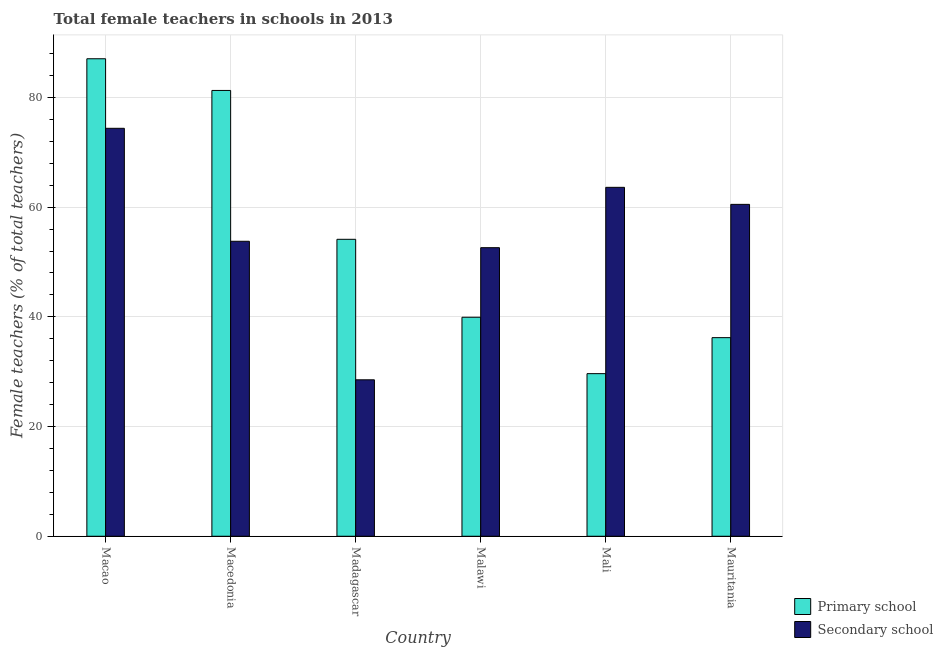Are the number of bars per tick equal to the number of legend labels?
Offer a terse response. Yes. How many bars are there on the 4th tick from the left?
Your response must be concise. 2. How many bars are there on the 6th tick from the right?
Your answer should be very brief. 2. What is the label of the 5th group of bars from the left?
Give a very brief answer. Mali. In how many cases, is the number of bars for a given country not equal to the number of legend labels?
Ensure brevity in your answer.  0. What is the percentage of female teachers in secondary schools in Mauritania?
Provide a short and direct response. 60.5. Across all countries, what is the maximum percentage of female teachers in primary schools?
Offer a terse response. 87.05. Across all countries, what is the minimum percentage of female teachers in primary schools?
Provide a succinct answer. 29.64. In which country was the percentage of female teachers in secondary schools maximum?
Ensure brevity in your answer.  Macao. In which country was the percentage of female teachers in primary schools minimum?
Your answer should be compact. Mali. What is the total percentage of female teachers in primary schools in the graph?
Your answer should be very brief. 328.24. What is the difference between the percentage of female teachers in secondary schools in Malawi and that in Mauritania?
Your answer should be very brief. -7.9. What is the difference between the percentage of female teachers in secondary schools in Mauritania and the percentage of female teachers in primary schools in Madagascar?
Make the answer very short. 6.37. What is the average percentage of female teachers in primary schools per country?
Provide a succinct answer. 54.71. What is the difference between the percentage of female teachers in primary schools and percentage of female teachers in secondary schools in Macao?
Ensure brevity in your answer.  12.68. In how many countries, is the percentage of female teachers in primary schools greater than 72 %?
Your answer should be compact. 2. What is the ratio of the percentage of female teachers in primary schools in Macao to that in Mali?
Your answer should be very brief. 2.94. Is the percentage of female teachers in secondary schools in Macao less than that in Macedonia?
Keep it short and to the point. No. What is the difference between the highest and the second highest percentage of female teachers in secondary schools?
Ensure brevity in your answer.  10.76. What is the difference between the highest and the lowest percentage of female teachers in primary schools?
Offer a very short reply. 57.41. In how many countries, is the percentage of female teachers in secondary schools greater than the average percentage of female teachers in secondary schools taken over all countries?
Offer a very short reply. 3. What does the 2nd bar from the left in Macedonia represents?
Make the answer very short. Secondary school. What does the 2nd bar from the right in Malawi represents?
Offer a very short reply. Primary school. Are all the bars in the graph horizontal?
Provide a succinct answer. No. What is the difference between two consecutive major ticks on the Y-axis?
Keep it short and to the point. 20. Does the graph contain any zero values?
Your response must be concise. No. What is the title of the graph?
Your answer should be compact. Total female teachers in schools in 2013. What is the label or title of the X-axis?
Ensure brevity in your answer.  Country. What is the label or title of the Y-axis?
Offer a terse response. Female teachers (% of total teachers). What is the Female teachers (% of total teachers) in Primary school in Macao?
Your answer should be very brief. 87.05. What is the Female teachers (% of total teachers) of Secondary school in Macao?
Your answer should be very brief. 74.37. What is the Female teachers (% of total teachers) of Primary school in Macedonia?
Provide a succinct answer. 81.27. What is the Female teachers (% of total teachers) of Secondary school in Macedonia?
Keep it short and to the point. 53.78. What is the Female teachers (% of total teachers) in Primary school in Madagascar?
Keep it short and to the point. 54.14. What is the Female teachers (% of total teachers) of Secondary school in Madagascar?
Provide a short and direct response. 28.52. What is the Female teachers (% of total teachers) of Primary school in Malawi?
Offer a very short reply. 39.93. What is the Female teachers (% of total teachers) of Secondary school in Malawi?
Your response must be concise. 52.61. What is the Female teachers (% of total teachers) in Primary school in Mali?
Give a very brief answer. 29.64. What is the Female teachers (% of total teachers) of Secondary school in Mali?
Make the answer very short. 63.61. What is the Female teachers (% of total teachers) of Primary school in Mauritania?
Offer a terse response. 36.21. What is the Female teachers (% of total teachers) of Secondary school in Mauritania?
Provide a short and direct response. 60.5. Across all countries, what is the maximum Female teachers (% of total teachers) in Primary school?
Give a very brief answer. 87.05. Across all countries, what is the maximum Female teachers (% of total teachers) of Secondary school?
Keep it short and to the point. 74.37. Across all countries, what is the minimum Female teachers (% of total teachers) in Primary school?
Provide a succinct answer. 29.64. Across all countries, what is the minimum Female teachers (% of total teachers) of Secondary school?
Your answer should be compact. 28.52. What is the total Female teachers (% of total teachers) in Primary school in the graph?
Provide a short and direct response. 328.24. What is the total Female teachers (% of total teachers) in Secondary school in the graph?
Ensure brevity in your answer.  333.39. What is the difference between the Female teachers (% of total teachers) of Primary school in Macao and that in Macedonia?
Offer a terse response. 5.78. What is the difference between the Female teachers (% of total teachers) of Secondary school in Macao and that in Macedonia?
Offer a terse response. 20.6. What is the difference between the Female teachers (% of total teachers) of Primary school in Macao and that in Madagascar?
Offer a terse response. 32.92. What is the difference between the Female teachers (% of total teachers) in Secondary school in Macao and that in Madagascar?
Offer a terse response. 45.85. What is the difference between the Female teachers (% of total teachers) in Primary school in Macao and that in Malawi?
Offer a very short reply. 47.13. What is the difference between the Female teachers (% of total teachers) of Secondary school in Macao and that in Malawi?
Your answer should be very brief. 21.76. What is the difference between the Female teachers (% of total teachers) in Primary school in Macao and that in Mali?
Offer a very short reply. 57.41. What is the difference between the Female teachers (% of total teachers) of Secondary school in Macao and that in Mali?
Ensure brevity in your answer.  10.76. What is the difference between the Female teachers (% of total teachers) in Primary school in Macao and that in Mauritania?
Offer a terse response. 50.84. What is the difference between the Female teachers (% of total teachers) in Secondary school in Macao and that in Mauritania?
Your answer should be very brief. 13.87. What is the difference between the Female teachers (% of total teachers) of Primary school in Macedonia and that in Madagascar?
Provide a short and direct response. 27.14. What is the difference between the Female teachers (% of total teachers) of Secondary school in Macedonia and that in Madagascar?
Your response must be concise. 25.26. What is the difference between the Female teachers (% of total teachers) of Primary school in Macedonia and that in Malawi?
Provide a short and direct response. 41.35. What is the difference between the Female teachers (% of total teachers) of Secondary school in Macedonia and that in Malawi?
Your answer should be compact. 1.17. What is the difference between the Female teachers (% of total teachers) of Primary school in Macedonia and that in Mali?
Offer a terse response. 51.63. What is the difference between the Female teachers (% of total teachers) in Secondary school in Macedonia and that in Mali?
Keep it short and to the point. -9.83. What is the difference between the Female teachers (% of total teachers) in Primary school in Macedonia and that in Mauritania?
Provide a short and direct response. 45.07. What is the difference between the Female teachers (% of total teachers) in Secondary school in Macedonia and that in Mauritania?
Provide a short and direct response. -6.73. What is the difference between the Female teachers (% of total teachers) of Primary school in Madagascar and that in Malawi?
Your answer should be compact. 14.21. What is the difference between the Female teachers (% of total teachers) of Secondary school in Madagascar and that in Malawi?
Offer a terse response. -24.09. What is the difference between the Female teachers (% of total teachers) in Primary school in Madagascar and that in Mali?
Provide a succinct answer. 24.49. What is the difference between the Female teachers (% of total teachers) of Secondary school in Madagascar and that in Mali?
Provide a short and direct response. -35.09. What is the difference between the Female teachers (% of total teachers) in Primary school in Madagascar and that in Mauritania?
Your answer should be compact. 17.93. What is the difference between the Female teachers (% of total teachers) in Secondary school in Madagascar and that in Mauritania?
Your response must be concise. -31.98. What is the difference between the Female teachers (% of total teachers) of Primary school in Malawi and that in Mali?
Offer a terse response. 10.28. What is the difference between the Female teachers (% of total teachers) in Secondary school in Malawi and that in Mali?
Your answer should be very brief. -11. What is the difference between the Female teachers (% of total teachers) in Primary school in Malawi and that in Mauritania?
Give a very brief answer. 3.72. What is the difference between the Female teachers (% of total teachers) of Secondary school in Malawi and that in Mauritania?
Offer a very short reply. -7.9. What is the difference between the Female teachers (% of total teachers) of Primary school in Mali and that in Mauritania?
Your answer should be very brief. -6.56. What is the difference between the Female teachers (% of total teachers) in Secondary school in Mali and that in Mauritania?
Your answer should be very brief. 3.11. What is the difference between the Female teachers (% of total teachers) in Primary school in Macao and the Female teachers (% of total teachers) in Secondary school in Macedonia?
Ensure brevity in your answer.  33.28. What is the difference between the Female teachers (% of total teachers) in Primary school in Macao and the Female teachers (% of total teachers) in Secondary school in Madagascar?
Offer a very short reply. 58.53. What is the difference between the Female teachers (% of total teachers) of Primary school in Macao and the Female teachers (% of total teachers) of Secondary school in Malawi?
Give a very brief answer. 34.44. What is the difference between the Female teachers (% of total teachers) of Primary school in Macao and the Female teachers (% of total teachers) of Secondary school in Mali?
Provide a succinct answer. 23.44. What is the difference between the Female teachers (% of total teachers) of Primary school in Macao and the Female teachers (% of total teachers) of Secondary school in Mauritania?
Make the answer very short. 26.55. What is the difference between the Female teachers (% of total teachers) in Primary school in Macedonia and the Female teachers (% of total teachers) in Secondary school in Madagascar?
Give a very brief answer. 52.75. What is the difference between the Female teachers (% of total teachers) of Primary school in Macedonia and the Female teachers (% of total teachers) of Secondary school in Malawi?
Ensure brevity in your answer.  28.67. What is the difference between the Female teachers (% of total teachers) of Primary school in Macedonia and the Female teachers (% of total teachers) of Secondary school in Mali?
Give a very brief answer. 17.66. What is the difference between the Female teachers (% of total teachers) in Primary school in Macedonia and the Female teachers (% of total teachers) in Secondary school in Mauritania?
Offer a terse response. 20.77. What is the difference between the Female teachers (% of total teachers) in Primary school in Madagascar and the Female teachers (% of total teachers) in Secondary school in Malawi?
Ensure brevity in your answer.  1.53. What is the difference between the Female teachers (% of total teachers) in Primary school in Madagascar and the Female teachers (% of total teachers) in Secondary school in Mali?
Offer a very short reply. -9.47. What is the difference between the Female teachers (% of total teachers) of Primary school in Madagascar and the Female teachers (% of total teachers) of Secondary school in Mauritania?
Offer a terse response. -6.37. What is the difference between the Female teachers (% of total teachers) of Primary school in Malawi and the Female teachers (% of total teachers) of Secondary school in Mali?
Your answer should be compact. -23.68. What is the difference between the Female teachers (% of total teachers) of Primary school in Malawi and the Female teachers (% of total teachers) of Secondary school in Mauritania?
Provide a short and direct response. -20.58. What is the difference between the Female teachers (% of total teachers) of Primary school in Mali and the Female teachers (% of total teachers) of Secondary school in Mauritania?
Make the answer very short. -30.86. What is the average Female teachers (% of total teachers) in Primary school per country?
Ensure brevity in your answer.  54.71. What is the average Female teachers (% of total teachers) in Secondary school per country?
Give a very brief answer. 55.57. What is the difference between the Female teachers (% of total teachers) in Primary school and Female teachers (% of total teachers) in Secondary school in Macao?
Provide a short and direct response. 12.68. What is the difference between the Female teachers (% of total teachers) of Primary school and Female teachers (% of total teachers) of Secondary school in Macedonia?
Make the answer very short. 27.5. What is the difference between the Female teachers (% of total teachers) in Primary school and Female teachers (% of total teachers) in Secondary school in Madagascar?
Keep it short and to the point. 25.62. What is the difference between the Female teachers (% of total teachers) of Primary school and Female teachers (% of total teachers) of Secondary school in Malawi?
Your answer should be very brief. -12.68. What is the difference between the Female teachers (% of total teachers) of Primary school and Female teachers (% of total teachers) of Secondary school in Mali?
Make the answer very short. -33.97. What is the difference between the Female teachers (% of total teachers) in Primary school and Female teachers (% of total teachers) in Secondary school in Mauritania?
Your answer should be very brief. -24.3. What is the ratio of the Female teachers (% of total teachers) in Primary school in Macao to that in Macedonia?
Your answer should be very brief. 1.07. What is the ratio of the Female teachers (% of total teachers) in Secondary school in Macao to that in Macedonia?
Your response must be concise. 1.38. What is the ratio of the Female teachers (% of total teachers) in Primary school in Macao to that in Madagascar?
Your answer should be compact. 1.61. What is the ratio of the Female teachers (% of total teachers) in Secondary school in Macao to that in Madagascar?
Your answer should be compact. 2.61. What is the ratio of the Female teachers (% of total teachers) in Primary school in Macao to that in Malawi?
Your response must be concise. 2.18. What is the ratio of the Female teachers (% of total teachers) in Secondary school in Macao to that in Malawi?
Offer a terse response. 1.41. What is the ratio of the Female teachers (% of total teachers) of Primary school in Macao to that in Mali?
Keep it short and to the point. 2.94. What is the ratio of the Female teachers (% of total teachers) in Secondary school in Macao to that in Mali?
Make the answer very short. 1.17. What is the ratio of the Female teachers (% of total teachers) in Primary school in Macao to that in Mauritania?
Your answer should be very brief. 2.4. What is the ratio of the Female teachers (% of total teachers) of Secondary school in Macao to that in Mauritania?
Provide a succinct answer. 1.23. What is the ratio of the Female teachers (% of total teachers) in Primary school in Macedonia to that in Madagascar?
Provide a succinct answer. 1.5. What is the ratio of the Female teachers (% of total teachers) of Secondary school in Macedonia to that in Madagascar?
Provide a short and direct response. 1.89. What is the ratio of the Female teachers (% of total teachers) of Primary school in Macedonia to that in Malawi?
Your answer should be compact. 2.04. What is the ratio of the Female teachers (% of total teachers) of Secondary school in Macedonia to that in Malawi?
Provide a succinct answer. 1.02. What is the ratio of the Female teachers (% of total teachers) of Primary school in Macedonia to that in Mali?
Your answer should be very brief. 2.74. What is the ratio of the Female teachers (% of total teachers) of Secondary school in Macedonia to that in Mali?
Ensure brevity in your answer.  0.85. What is the ratio of the Female teachers (% of total teachers) of Primary school in Macedonia to that in Mauritania?
Provide a short and direct response. 2.24. What is the ratio of the Female teachers (% of total teachers) in Secondary school in Macedonia to that in Mauritania?
Offer a very short reply. 0.89. What is the ratio of the Female teachers (% of total teachers) of Primary school in Madagascar to that in Malawi?
Keep it short and to the point. 1.36. What is the ratio of the Female teachers (% of total teachers) in Secondary school in Madagascar to that in Malawi?
Provide a short and direct response. 0.54. What is the ratio of the Female teachers (% of total teachers) of Primary school in Madagascar to that in Mali?
Offer a very short reply. 1.83. What is the ratio of the Female teachers (% of total teachers) of Secondary school in Madagascar to that in Mali?
Give a very brief answer. 0.45. What is the ratio of the Female teachers (% of total teachers) of Primary school in Madagascar to that in Mauritania?
Give a very brief answer. 1.5. What is the ratio of the Female teachers (% of total teachers) of Secondary school in Madagascar to that in Mauritania?
Your response must be concise. 0.47. What is the ratio of the Female teachers (% of total teachers) of Primary school in Malawi to that in Mali?
Your answer should be compact. 1.35. What is the ratio of the Female teachers (% of total teachers) of Secondary school in Malawi to that in Mali?
Your answer should be compact. 0.83. What is the ratio of the Female teachers (% of total teachers) of Primary school in Malawi to that in Mauritania?
Make the answer very short. 1.1. What is the ratio of the Female teachers (% of total teachers) in Secondary school in Malawi to that in Mauritania?
Make the answer very short. 0.87. What is the ratio of the Female teachers (% of total teachers) in Primary school in Mali to that in Mauritania?
Ensure brevity in your answer.  0.82. What is the ratio of the Female teachers (% of total teachers) of Secondary school in Mali to that in Mauritania?
Keep it short and to the point. 1.05. What is the difference between the highest and the second highest Female teachers (% of total teachers) in Primary school?
Provide a short and direct response. 5.78. What is the difference between the highest and the second highest Female teachers (% of total teachers) in Secondary school?
Offer a very short reply. 10.76. What is the difference between the highest and the lowest Female teachers (% of total teachers) of Primary school?
Offer a terse response. 57.41. What is the difference between the highest and the lowest Female teachers (% of total teachers) in Secondary school?
Your answer should be compact. 45.85. 